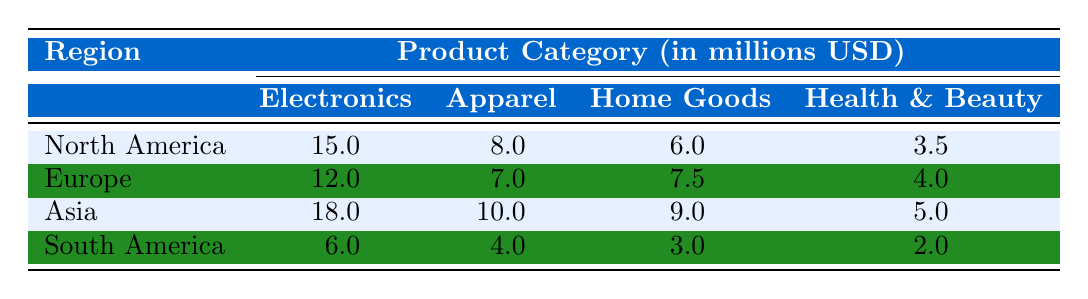What is the total revenue from Electronics in North America? According to the table, the revenue from Electronics in North America is listed as 15.0 million USD.
Answer: 15.0 million USD Which region has the highest revenue from Home Goods? By examining the table, the revenue from Home Goods in Asia is 9.0 million USD, which is the highest value compared to other regions. North America has 6.0 million, Europe has 7.5 million, and South America has 3.0 million.
Answer: Asia What is the combined revenue from Apparel in Europe and South America? The revenue for Apparel in Europe is 7.0 million USD and in South America it is 4.0 million USD. Combining these values gives 7.0 + 4.0 = 11.0 million USD.
Answer: 11.0 million USD Is the revenue from Health & Beauty in Europe greater than that in North America? The table shows that revenue from Health & Beauty in Europe is 4.0 million USD, and in North America, it is 3.5 million USD. Since 4.0 million is greater than 3.5 million, this statement is true.
Answer: Yes What is the average revenue for Electronics across all regions? The revenues for Electronics in the respective regions are as follows: North America 15.0 million, Europe 12.0 million, Asia 18.0 million, and South America 6.0 million. To find the average, we calculate (15 + 12 + 18 + 6) / 4 = 51 / 4 = 12.75 million USD.
Answer: 12.75 million USD Which category has the lowest revenue in South America? In South America, the revenues are: Electronics 6.0 million, Apparel 4.0 million, Home Goods 3.0 million, and Health & Beauty 2.0 million. The category with the lowest revenue is Health & Beauty, which has 2.0 million USD.
Answer: Health & Beauty What is the difference in revenue from Apparel between Asia and Europe? The revenue for Apparel in Asia is 10.0 million USD, while in Europe it is 7.0 million USD. To find the difference, we subtract: 10.0 million - 7.0 million = 3.0 million USD.
Answer: 3.0 million USD Is the total revenue from all categories in North America more than 40 million USD? To evaluate this, we sum the revenues from all categories in North America: 15.0 (Electronics) + 8.0 (Apparel) + 6.0 (Home Goods) + 3.5 (Health & Beauty) = 32.5 million USD. Since 32.5 million is less than 40 million, the answer is no.
Answer: No What is the combined revenue for Electronics and Health & Beauty in Asia? The revenue from Electronics in Asia is 18.0 million USD and from Health & Beauty is 5.0 million USD. Combining these yields 18.0 + 5.0 = 23.0 million USD.
Answer: 23.0 million USD 